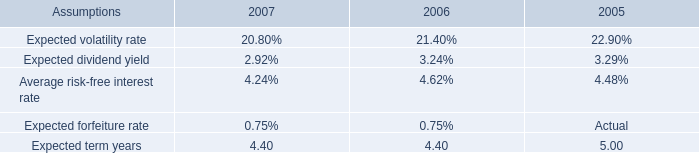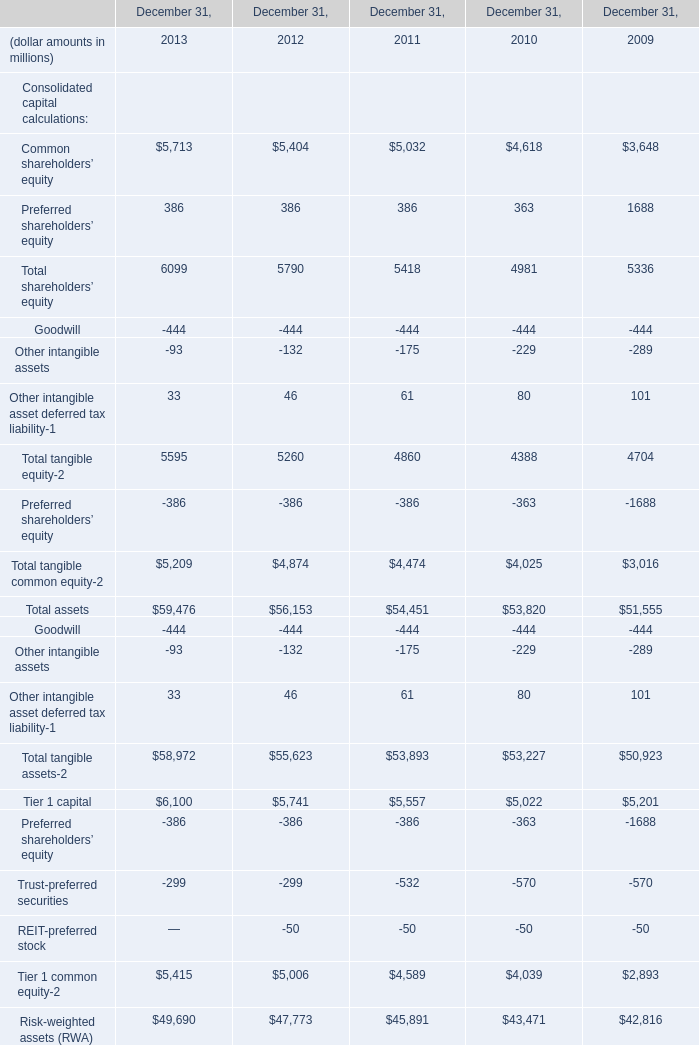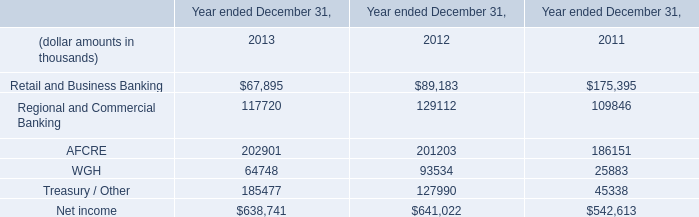What's the increasing rate of Common shareholders’ equity in 2012? 
Computations: ((5404 - 5032) / 5032)
Answer: 0.07393. 